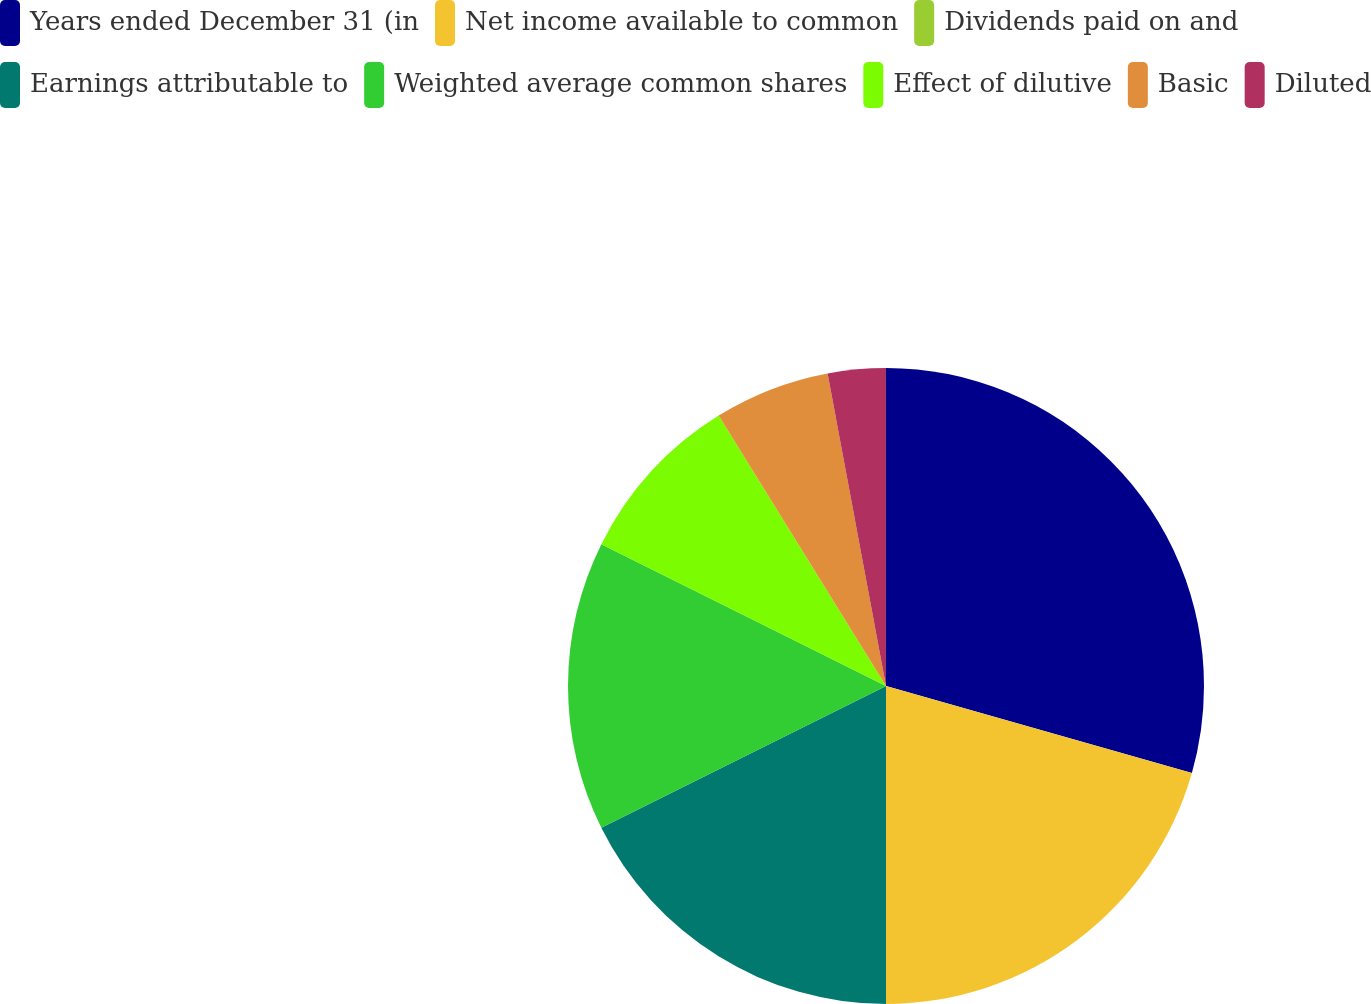Convert chart. <chart><loc_0><loc_0><loc_500><loc_500><pie_chart><fcel>Years ended December 31 (in<fcel>Net income available to common<fcel>Dividends paid on and<fcel>Earnings attributable to<fcel>Weighted average common shares<fcel>Effect of dilutive<fcel>Basic<fcel>Diluted<nl><fcel>29.41%<fcel>20.59%<fcel>0.0%<fcel>17.65%<fcel>14.71%<fcel>8.82%<fcel>5.88%<fcel>2.94%<nl></chart> 